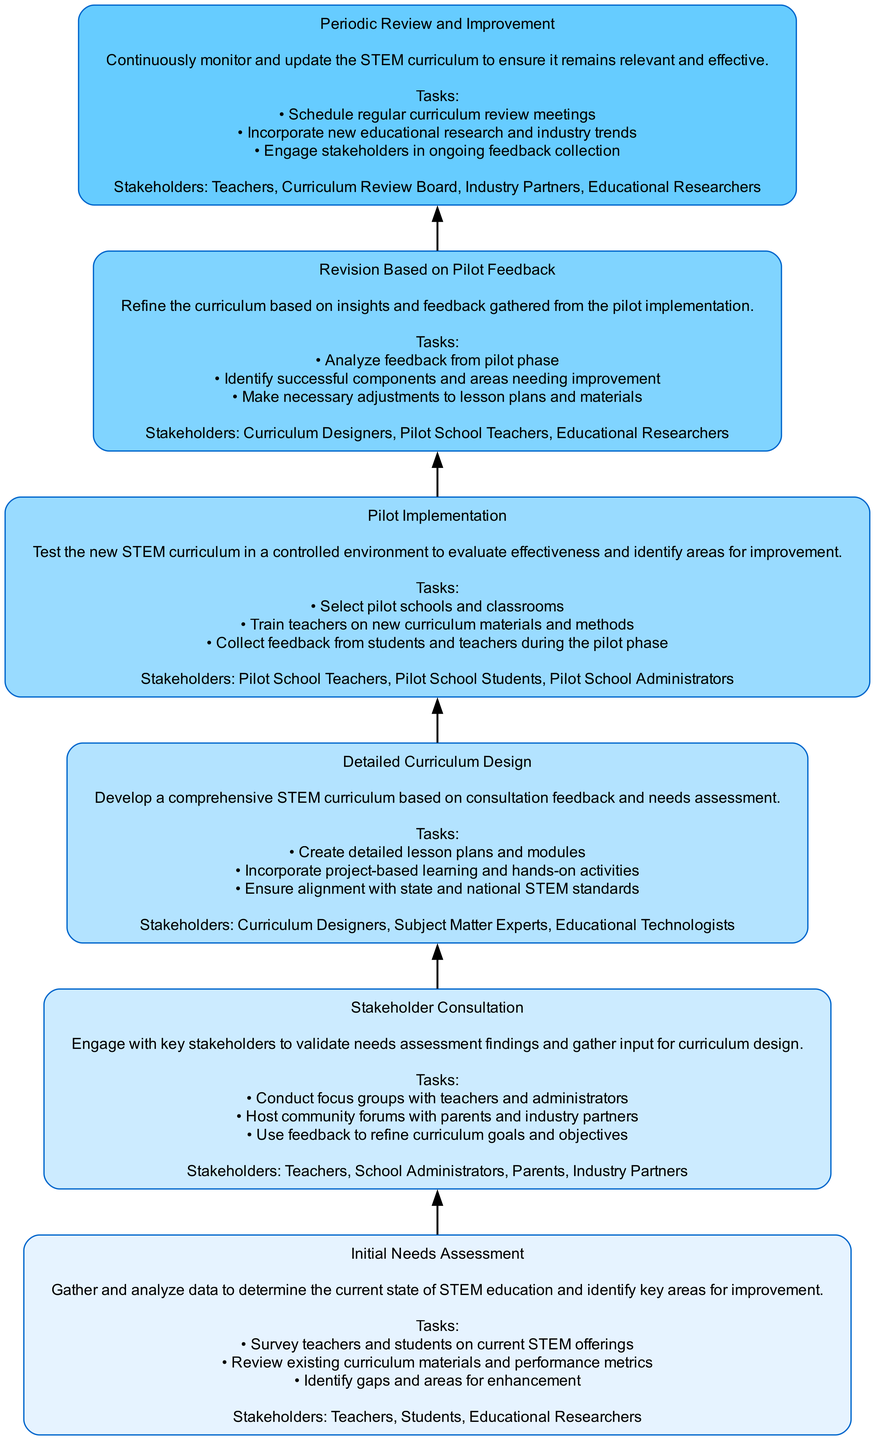What is the top element in the flowchart? The top element in the flowchart is "Periodic Review and Improvement," which is the last step that incorporates ongoing feedback and ensures curriculum effectiveness.
Answer: Periodic Review and Improvement How many total nodes are in the diagram? The diagram contains six nodes, each representing a different stage in the iterative development of the STEM curriculum from initial needs assessment to periodic review.
Answer: 6 What is the direct connection between "Pilot Implementation" and "Revision Based on Pilot Feedback"? "Pilot Implementation" directly leads to "Revision Based on Pilot Feedback," signifying that feedback obtained during the pilot phase is essential for refining the curriculum.
Answer: Revision Based on Pilot Feedback Who are the stakeholders in the "Detailed Curriculum Design" phase? The stakeholders involved in this phase include Curriculum Designers, Subject Matter Experts, and Educational Technologists, all of whom contribute expertise to develop the curriculum.
Answer: Curriculum Designers, Subject Matter Experts, Educational Technologists What tasks are involved in the "Initial Needs Assessment" phase? The tasks in this phase include surveying teachers and students, reviewing existing curriculum materials, and identifying gaps in STEM offerings, which provide foundational data for later stages.
Answer: Survey teachers and students on current STEM offerings, Review existing curriculum materials and performance metrics, Identify gaps and areas for enhancement What phase comes after "Stakeholder Consultation"? After "Stakeholder Consultation," the next phase in the flowchart is "Detailed Curriculum Design," indicating that stakeholder feedback is used to inform the design of the curriculum.
Answer: Detailed Curriculum Design 